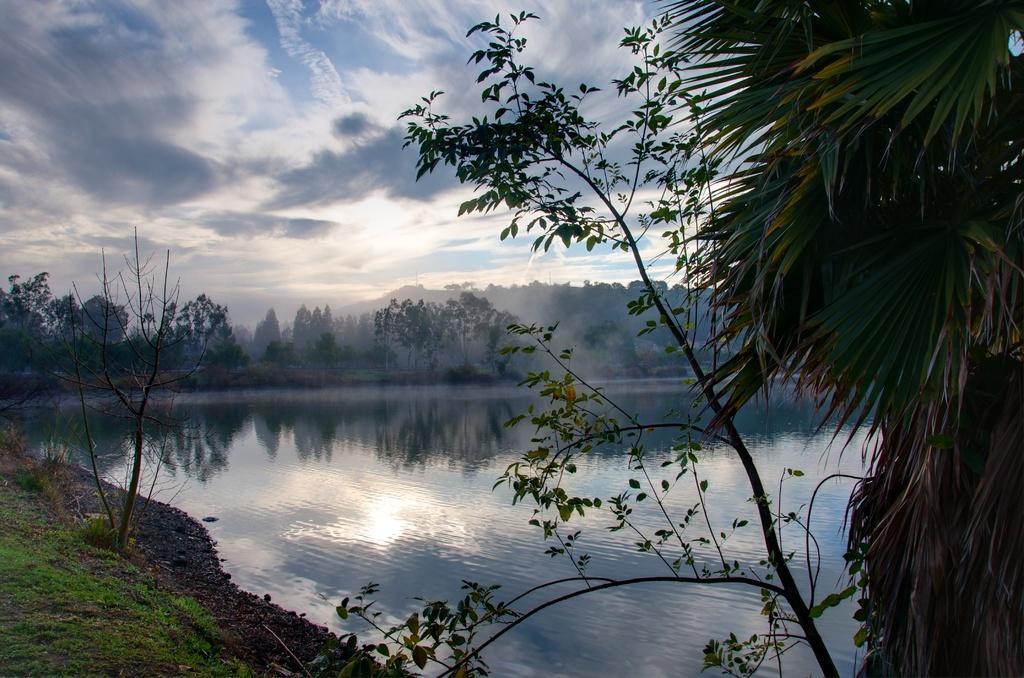Can you describe this image briefly? In this picture there is a beautiful view of the river water. Behind there are some trees. On the right corner there is a coconut tree. 